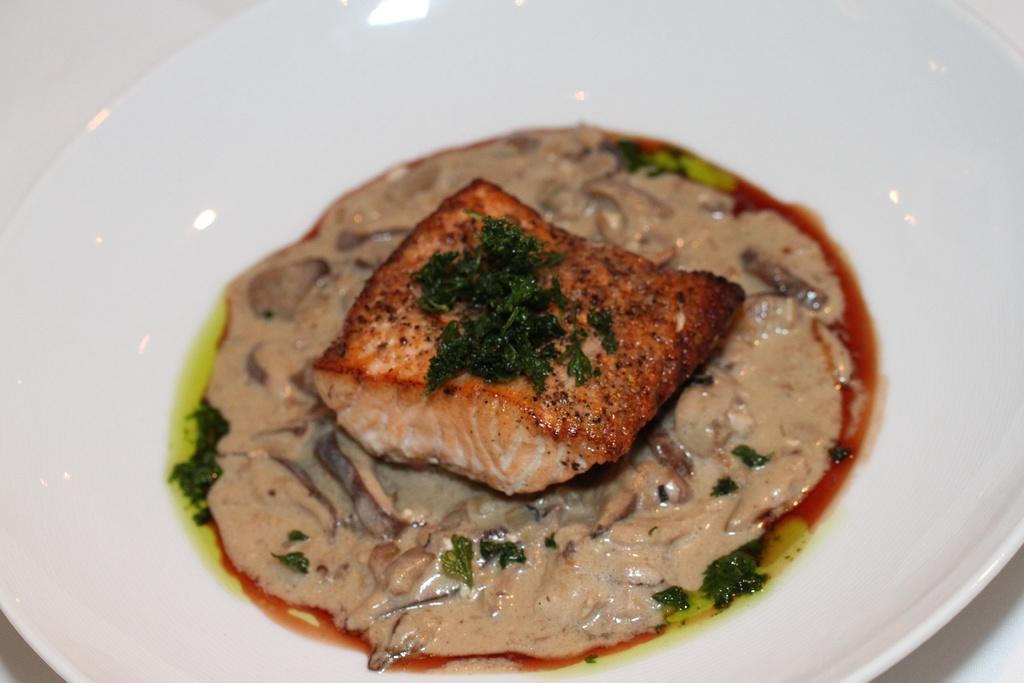Please provide a concise description of this image. In this image we can see food placed in a bowl kept on the surface. 